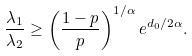<formula> <loc_0><loc_0><loc_500><loc_500>\frac { \lambda _ { 1 } } { \lambda _ { 2 } } \geq \left ( \frac { 1 - p } { p } \right ) ^ { 1 / \alpha } e ^ { d _ { 0 } / 2 \alpha } .</formula> 